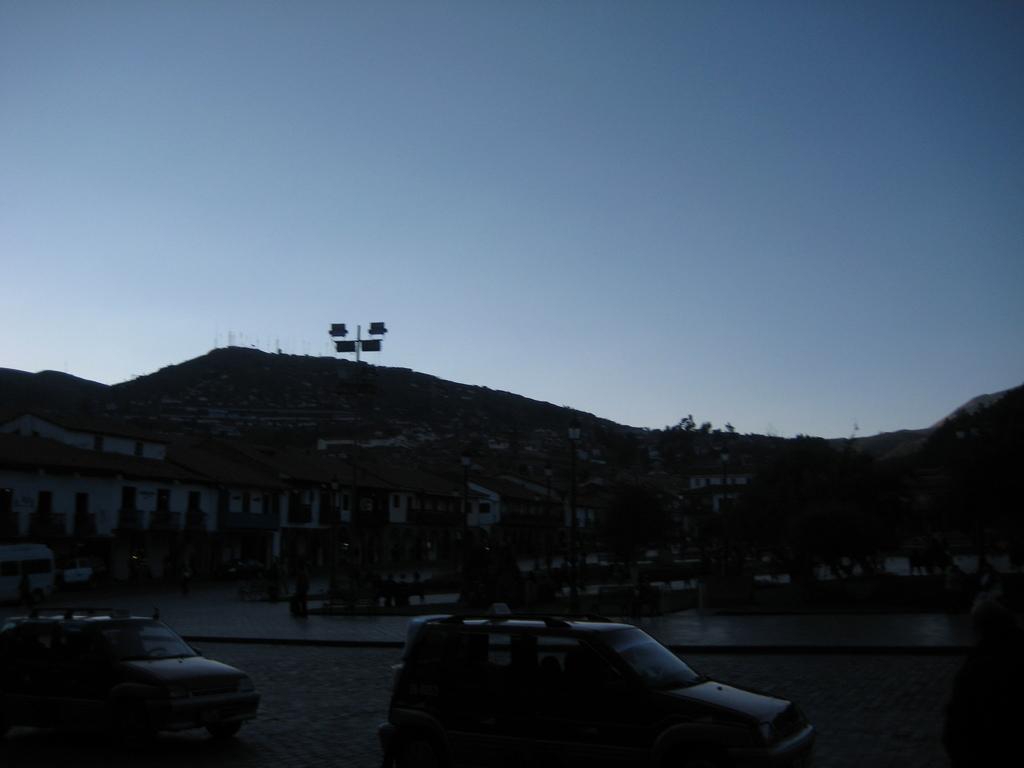Could you give a brief overview of what you see in this image? In this image, we can see the vehicles and path. In the background, there are street lights, plants, buildings, trees, hills and few objects. At the top of the image, there is the sky. 